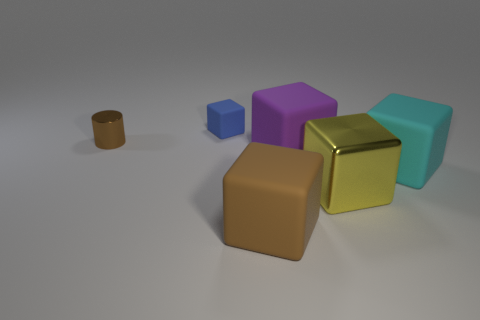What material is the big block that is the same color as the metal cylinder?
Ensure brevity in your answer.  Rubber. Is the material of the block that is behind the brown cylinder the same as the big yellow block?
Offer a very short reply. No. There is a large rubber cube in front of the large rubber block that is to the right of the big purple matte thing; is there a small blue object in front of it?
Provide a succinct answer. No. How many cubes are either brown things or large objects?
Offer a very short reply. 4. There is a tiny brown cylinder on the left side of the small cube; what is its material?
Your answer should be compact. Metal. There is a matte block that is the same color as the metallic cylinder; what size is it?
Provide a short and direct response. Large. There is a object left of the small rubber block; is it the same color as the metal object that is on the right side of the blue cube?
Your response must be concise. No. How many objects are big brown objects or green shiny balls?
Keep it short and to the point. 1. How many other objects are there of the same shape as the purple rubber thing?
Give a very brief answer. 4. Is the material of the cube that is on the left side of the big brown object the same as the brown thing behind the big purple cube?
Your response must be concise. No. 